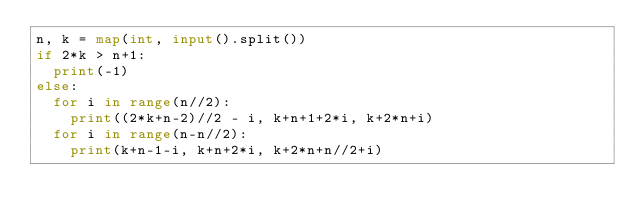<code> <loc_0><loc_0><loc_500><loc_500><_Python_>n, k = map(int, input().split())
if 2*k > n+1:
	print(-1)
else:
	for i in range(n//2):
		print((2*k+n-2)//2 - i, k+n+1+2*i, k+2*n+i)
	for i in range(n-n//2):
		print(k+n-1-i, k+n+2*i, k+2*n+n//2+i)</code> 